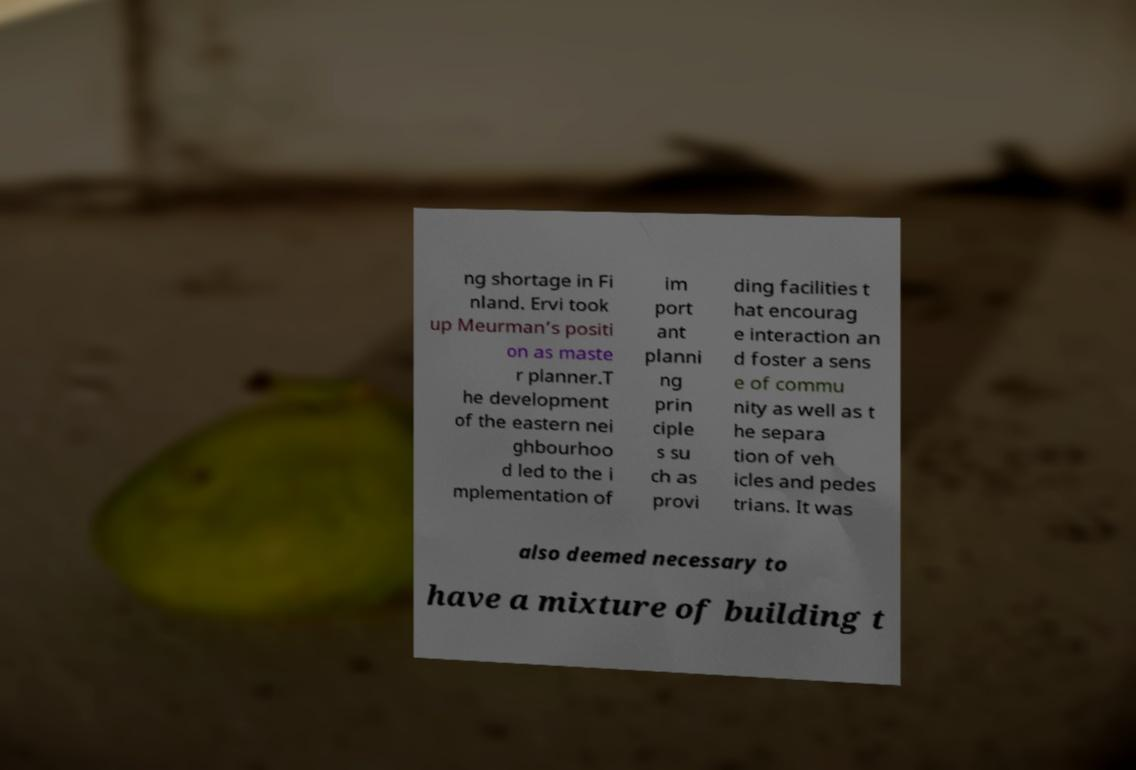There's text embedded in this image that I need extracted. Can you transcribe it verbatim? ng shortage in Fi nland. Ervi took up Meurman’s positi on as maste r planner.T he development of the eastern nei ghbourhoo d led to the i mplementation of im port ant planni ng prin ciple s su ch as provi ding facilities t hat encourag e interaction an d foster a sens e of commu nity as well as t he separa tion of veh icles and pedes trians. It was also deemed necessary to have a mixture of building t 